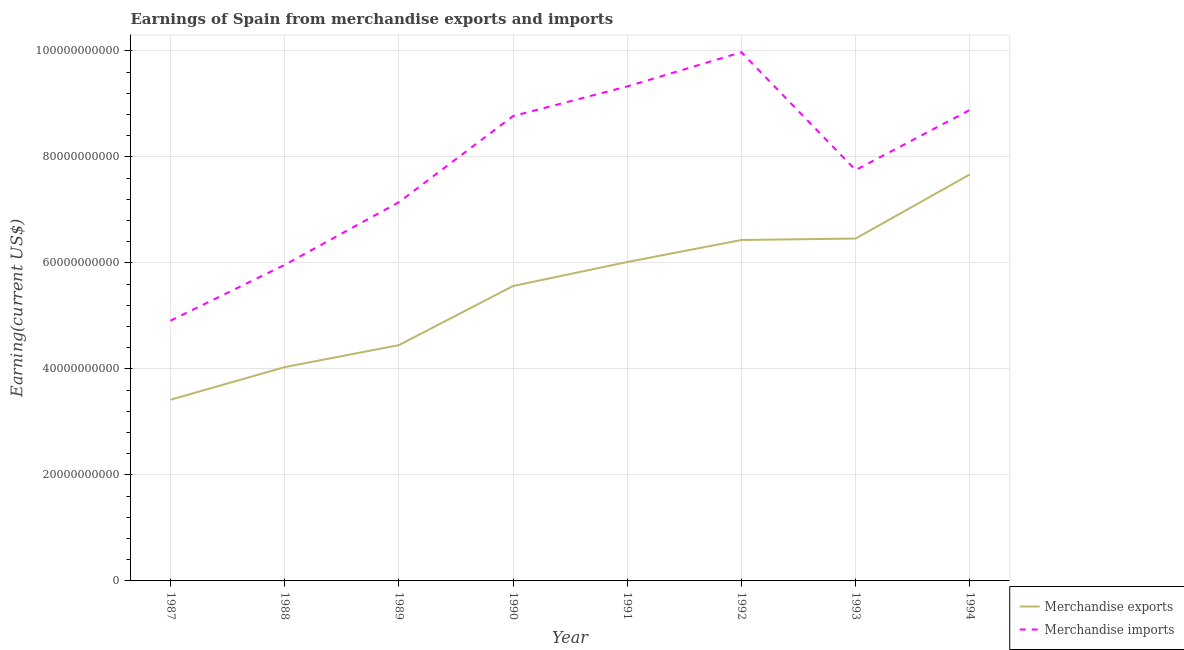Does the line corresponding to earnings from merchandise imports intersect with the line corresponding to earnings from merchandise exports?
Your response must be concise. No. Is the number of lines equal to the number of legend labels?
Your response must be concise. Yes. What is the earnings from merchandise imports in 1990?
Provide a succinct answer. 8.77e+1. Across all years, what is the maximum earnings from merchandise imports?
Ensure brevity in your answer.  9.98e+1. Across all years, what is the minimum earnings from merchandise exports?
Your response must be concise. 3.42e+1. In which year was the earnings from merchandise imports maximum?
Your answer should be compact. 1992. What is the total earnings from merchandise exports in the graph?
Offer a very short reply. 4.40e+11. What is the difference between the earnings from merchandise imports in 1991 and that in 1992?
Keep it short and to the point. -6.45e+09. What is the difference between the earnings from merchandise exports in 1991 and the earnings from merchandise imports in 1989?
Your response must be concise. -1.13e+1. What is the average earnings from merchandise imports per year?
Your answer should be compact. 7.84e+1. In the year 1991, what is the difference between the earnings from merchandise exports and earnings from merchandise imports?
Ensure brevity in your answer.  -3.31e+1. In how many years, is the earnings from merchandise imports greater than 16000000000 US$?
Give a very brief answer. 8. What is the ratio of the earnings from merchandise imports in 1987 to that in 1989?
Make the answer very short. 0.69. Is the earnings from merchandise exports in 1991 less than that in 1993?
Your response must be concise. Yes. What is the difference between the highest and the second highest earnings from merchandise exports?
Offer a very short reply. 1.21e+1. What is the difference between the highest and the lowest earnings from merchandise imports?
Provide a succinct answer. 5.06e+1. Is the earnings from merchandise imports strictly greater than the earnings from merchandise exports over the years?
Make the answer very short. Yes. How many lines are there?
Ensure brevity in your answer.  2. How many years are there in the graph?
Your answer should be compact. 8. What is the difference between two consecutive major ticks on the Y-axis?
Provide a short and direct response. 2.00e+1. Are the values on the major ticks of Y-axis written in scientific E-notation?
Keep it short and to the point. No. Does the graph contain any zero values?
Make the answer very short. No. Does the graph contain grids?
Ensure brevity in your answer.  Yes. Where does the legend appear in the graph?
Offer a very short reply. Bottom right. What is the title of the graph?
Your response must be concise. Earnings of Spain from merchandise exports and imports. What is the label or title of the X-axis?
Provide a short and direct response. Year. What is the label or title of the Y-axis?
Provide a succinct answer. Earning(current US$). What is the Earning(current US$) in Merchandise exports in 1987?
Provide a short and direct response. 3.42e+1. What is the Earning(current US$) of Merchandise imports in 1987?
Keep it short and to the point. 4.91e+1. What is the Earning(current US$) of Merchandise exports in 1988?
Your answer should be very brief. 4.03e+1. What is the Earning(current US$) of Merchandise imports in 1988?
Your answer should be very brief. 5.96e+1. What is the Earning(current US$) in Merchandise exports in 1989?
Offer a very short reply. 4.45e+1. What is the Earning(current US$) of Merchandise imports in 1989?
Give a very brief answer. 7.15e+1. What is the Earning(current US$) in Merchandise exports in 1990?
Keep it short and to the point. 5.56e+1. What is the Earning(current US$) of Merchandise imports in 1990?
Offer a very short reply. 8.77e+1. What is the Earning(current US$) in Merchandise exports in 1991?
Ensure brevity in your answer.  6.02e+1. What is the Earning(current US$) in Merchandise imports in 1991?
Offer a terse response. 9.33e+1. What is the Earning(current US$) in Merchandise exports in 1992?
Provide a short and direct response. 6.43e+1. What is the Earning(current US$) of Merchandise imports in 1992?
Provide a short and direct response. 9.98e+1. What is the Earning(current US$) in Merchandise exports in 1993?
Ensure brevity in your answer.  6.46e+1. What is the Earning(current US$) of Merchandise imports in 1993?
Ensure brevity in your answer.  7.75e+1. What is the Earning(current US$) in Merchandise exports in 1994?
Offer a terse response. 7.67e+1. What is the Earning(current US$) in Merchandise imports in 1994?
Provide a short and direct response. 8.89e+1. Across all years, what is the maximum Earning(current US$) of Merchandise exports?
Your answer should be very brief. 7.67e+1. Across all years, what is the maximum Earning(current US$) of Merchandise imports?
Keep it short and to the point. 9.98e+1. Across all years, what is the minimum Earning(current US$) in Merchandise exports?
Offer a terse response. 3.42e+1. Across all years, what is the minimum Earning(current US$) of Merchandise imports?
Make the answer very short. 4.91e+1. What is the total Earning(current US$) of Merchandise exports in the graph?
Make the answer very short. 4.40e+11. What is the total Earning(current US$) of Merchandise imports in the graph?
Your answer should be compact. 6.27e+11. What is the difference between the Earning(current US$) of Merchandise exports in 1987 and that in 1988?
Keep it short and to the point. -6.15e+09. What is the difference between the Earning(current US$) of Merchandise imports in 1987 and that in 1988?
Keep it short and to the point. -1.05e+1. What is the difference between the Earning(current US$) in Merchandise exports in 1987 and that in 1989?
Ensure brevity in your answer.  -1.03e+1. What is the difference between the Earning(current US$) of Merchandise imports in 1987 and that in 1989?
Keep it short and to the point. -2.24e+1. What is the difference between the Earning(current US$) of Merchandise exports in 1987 and that in 1990?
Give a very brief answer. -2.14e+1. What is the difference between the Earning(current US$) in Merchandise imports in 1987 and that in 1990?
Make the answer very short. -3.86e+1. What is the difference between the Earning(current US$) in Merchandise exports in 1987 and that in 1991?
Your answer should be very brief. -2.60e+1. What is the difference between the Earning(current US$) in Merchandise imports in 1987 and that in 1991?
Make the answer very short. -4.42e+1. What is the difference between the Earning(current US$) of Merchandise exports in 1987 and that in 1992?
Your response must be concise. -3.01e+1. What is the difference between the Earning(current US$) of Merchandise imports in 1987 and that in 1992?
Your answer should be compact. -5.06e+1. What is the difference between the Earning(current US$) in Merchandise exports in 1987 and that in 1993?
Ensure brevity in your answer.  -3.04e+1. What is the difference between the Earning(current US$) in Merchandise imports in 1987 and that in 1993?
Keep it short and to the point. -2.84e+1. What is the difference between the Earning(current US$) in Merchandise exports in 1987 and that in 1994?
Give a very brief answer. -4.25e+1. What is the difference between the Earning(current US$) of Merchandise imports in 1987 and that in 1994?
Make the answer very short. -3.98e+1. What is the difference between the Earning(current US$) in Merchandise exports in 1988 and that in 1989?
Offer a very short reply. -4.15e+09. What is the difference between the Earning(current US$) of Merchandise imports in 1988 and that in 1989?
Your response must be concise. -1.18e+1. What is the difference between the Earning(current US$) of Merchandise exports in 1988 and that in 1990?
Give a very brief answer. -1.53e+1. What is the difference between the Earning(current US$) of Merchandise imports in 1988 and that in 1990?
Offer a terse response. -2.81e+1. What is the difference between the Earning(current US$) of Merchandise exports in 1988 and that in 1991?
Keep it short and to the point. -1.98e+1. What is the difference between the Earning(current US$) in Merchandise imports in 1988 and that in 1991?
Provide a succinct answer. -3.37e+1. What is the difference between the Earning(current US$) in Merchandise exports in 1988 and that in 1992?
Ensure brevity in your answer.  -2.40e+1. What is the difference between the Earning(current US$) of Merchandise imports in 1988 and that in 1992?
Ensure brevity in your answer.  -4.01e+1. What is the difference between the Earning(current US$) of Merchandise exports in 1988 and that in 1993?
Make the answer very short. -2.43e+1. What is the difference between the Earning(current US$) of Merchandise imports in 1988 and that in 1993?
Give a very brief answer. -1.79e+1. What is the difference between the Earning(current US$) in Merchandise exports in 1988 and that in 1994?
Make the answer very short. -3.64e+1. What is the difference between the Earning(current US$) of Merchandise imports in 1988 and that in 1994?
Provide a succinct answer. -2.92e+1. What is the difference between the Earning(current US$) in Merchandise exports in 1989 and that in 1990?
Provide a succinct answer. -1.12e+1. What is the difference between the Earning(current US$) in Merchandise imports in 1989 and that in 1990?
Keep it short and to the point. -1.62e+1. What is the difference between the Earning(current US$) in Merchandise exports in 1989 and that in 1991?
Your response must be concise. -1.57e+1. What is the difference between the Earning(current US$) of Merchandise imports in 1989 and that in 1991?
Your answer should be compact. -2.18e+1. What is the difference between the Earning(current US$) of Merchandise exports in 1989 and that in 1992?
Provide a short and direct response. -1.98e+1. What is the difference between the Earning(current US$) of Merchandise imports in 1989 and that in 1992?
Your response must be concise. -2.83e+1. What is the difference between the Earning(current US$) of Merchandise exports in 1989 and that in 1993?
Your answer should be very brief. -2.01e+1. What is the difference between the Earning(current US$) of Merchandise imports in 1989 and that in 1993?
Your response must be concise. -6.06e+09. What is the difference between the Earning(current US$) of Merchandise exports in 1989 and that in 1994?
Keep it short and to the point. -3.22e+1. What is the difference between the Earning(current US$) in Merchandise imports in 1989 and that in 1994?
Make the answer very short. -1.74e+1. What is the difference between the Earning(current US$) in Merchandise exports in 1990 and that in 1991?
Give a very brief answer. -4.54e+09. What is the difference between the Earning(current US$) of Merchandise imports in 1990 and that in 1991?
Ensure brevity in your answer.  -5.59e+09. What is the difference between the Earning(current US$) of Merchandise exports in 1990 and that in 1992?
Your answer should be compact. -8.69e+09. What is the difference between the Earning(current US$) in Merchandise imports in 1990 and that in 1992?
Your answer should be compact. -1.20e+1. What is the difference between the Earning(current US$) of Merchandise exports in 1990 and that in 1993?
Your answer should be very brief. -8.96e+09. What is the difference between the Earning(current US$) in Merchandise imports in 1990 and that in 1993?
Keep it short and to the point. 1.02e+1. What is the difference between the Earning(current US$) in Merchandise exports in 1990 and that in 1994?
Your answer should be very brief. -2.11e+1. What is the difference between the Earning(current US$) of Merchandise imports in 1990 and that in 1994?
Your answer should be very brief. -1.15e+09. What is the difference between the Earning(current US$) of Merchandise exports in 1991 and that in 1992?
Offer a terse response. -4.16e+09. What is the difference between the Earning(current US$) in Merchandise imports in 1991 and that in 1992?
Your response must be concise. -6.45e+09. What is the difference between the Earning(current US$) of Merchandise exports in 1991 and that in 1993?
Ensure brevity in your answer.  -4.43e+09. What is the difference between the Earning(current US$) in Merchandise imports in 1991 and that in 1993?
Make the answer very short. 1.58e+1. What is the difference between the Earning(current US$) in Merchandise exports in 1991 and that in 1994?
Your answer should be very brief. -1.65e+1. What is the difference between the Earning(current US$) in Merchandise imports in 1991 and that in 1994?
Offer a terse response. 4.44e+09. What is the difference between the Earning(current US$) in Merchandise exports in 1992 and that in 1993?
Offer a terse response. -2.69e+08. What is the difference between the Earning(current US$) in Merchandise imports in 1992 and that in 1993?
Give a very brief answer. 2.22e+1. What is the difference between the Earning(current US$) in Merchandise exports in 1992 and that in 1994?
Make the answer very short. -1.24e+1. What is the difference between the Earning(current US$) in Merchandise imports in 1992 and that in 1994?
Provide a short and direct response. 1.09e+1. What is the difference between the Earning(current US$) of Merchandise exports in 1993 and that in 1994?
Provide a succinct answer. -1.21e+1. What is the difference between the Earning(current US$) in Merchandise imports in 1993 and that in 1994?
Provide a succinct answer. -1.13e+1. What is the difference between the Earning(current US$) in Merchandise exports in 1987 and the Earning(current US$) in Merchandise imports in 1988?
Make the answer very short. -2.55e+1. What is the difference between the Earning(current US$) in Merchandise exports in 1987 and the Earning(current US$) in Merchandise imports in 1989?
Your response must be concise. -3.73e+1. What is the difference between the Earning(current US$) of Merchandise exports in 1987 and the Earning(current US$) of Merchandise imports in 1990?
Provide a succinct answer. -5.35e+1. What is the difference between the Earning(current US$) in Merchandise exports in 1987 and the Earning(current US$) in Merchandise imports in 1991?
Keep it short and to the point. -5.91e+1. What is the difference between the Earning(current US$) in Merchandise exports in 1987 and the Earning(current US$) in Merchandise imports in 1992?
Give a very brief answer. -6.56e+1. What is the difference between the Earning(current US$) of Merchandise exports in 1987 and the Earning(current US$) of Merchandise imports in 1993?
Offer a terse response. -4.33e+1. What is the difference between the Earning(current US$) in Merchandise exports in 1987 and the Earning(current US$) in Merchandise imports in 1994?
Your response must be concise. -5.47e+1. What is the difference between the Earning(current US$) of Merchandise exports in 1988 and the Earning(current US$) of Merchandise imports in 1989?
Keep it short and to the point. -3.11e+1. What is the difference between the Earning(current US$) of Merchandise exports in 1988 and the Earning(current US$) of Merchandise imports in 1990?
Give a very brief answer. -4.74e+1. What is the difference between the Earning(current US$) in Merchandise exports in 1988 and the Earning(current US$) in Merchandise imports in 1991?
Give a very brief answer. -5.30e+1. What is the difference between the Earning(current US$) of Merchandise exports in 1988 and the Earning(current US$) of Merchandise imports in 1992?
Offer a very short reply. -5.94e+1. What is the difference between the Earning(current US$) in Merchandise exports in 1988 and the Earning(current US$) in Merchandise imports in 1993?
Provide a short and direct response. -3.72e+1. What is the difference between the Earning(current US$) of Merchandise exports in 1988 and the Earning(current US$) of Merchandise imports in 1994?
Offer a very short reply. -4.85e+1. What is the difference between the Earning(current US$) in Merchandise exports in 1989 and the Earning(current US$) in Merchandise imports in 1990?
Your response must be concise. -4.32e+1. What is the difference between the Earning(current US$) of Merchandise exports in 1989 and the Earning(current US$) of Merchandise imports in 1991?
Provide a succinct answer. -4.88e+1. What is the difference between the Earning(current US$) of Merchandise exports in 1989 and the Earning(current US$) of Merchandise imports in 1992?
Your answer should be very brief. -5.53e+1. What is the difference between the Earning(current US$) in Merchandise exports in 1989 and the Earning(current US$) in Merchandise imports in 1993?
Your answer should be very brief. -3.30e+1. What is the difference between the Earning(current US$) of Merchandise exports in 1989 and the Earning(current US$) of Merchandise imports in 1994?
Offer a terse response. -4.44e+1. What is the difference between the Earning(current US$) of Merchandise exports in 1990 and the Earning(current US$) of Merchandise imports in 1991?
Offer a very short reply. -3.77e+1. What is the difference between the Earning(current US$) in Merchandise exports in 1990 and the Earning(current US$) in Merchandise imports in 1992?
Make the answer very short. -4.41e+1. What is the difference between the Earning(current US$) of Merchandise exports in 1990 and the Earning(current US$) of Merchandise imports in 1993?
Your answer should be very brief. -2.19e+1. What is the difference between the Earning(current US$) in Merchandise exports in 1990 and the Earning(current US$) in Merchandise imports in 1994?
Offer a very short reply. -3.32e+1. What is the difference between the Earning(current US$) in Merchandise exports in 1991 and the Earning(current US$) in Merchandise imports in 1992?
Offer a very short reply. -3.96e+1. What is the difference between the Earning(current US$) in Merchandise exports in 1991 and the Earning(current US$) in Merchandise imports in 1993?
Offer a very short reply. -1.73e+1. What is the difference between the Earning(current US$) of Merchandise exports in 1991 and the Earning(current US$) of Merchandise imports in 1994?
Offer a very short reply. -2.87e+1. What is the difference between the Earning(current US$) in Merchandise exports in 1992 and the Earning(current US$) in Merchandise imports in 1993?
Provide a short and direct response. -1.32e+1. What is the difference between the Earning(current US$) of Merchandise exports in 1992 and the Earning(current US$) of Merchandise imports in 1994?
Provide a succinct answer. -2.45e+1. What is the difference between the Earning(current US$) of Merchandise exports in 1993 and the Earning(current US$) of Merchandise imports in 1994?
Make the answer very short. -2.43e+1. What is the average Earning(current US$) in Merchandise exports per year?
Make the answer very short. 5.51e+1. What is the average Earning(current US$) in Merchandise imports per year?
Your response must be concise. 7.84e+1. In the year 1987, what is the difference between the Earning(current US$) of Merchandise exports and Earning(current US$) of Merchandise imports?
Make the answer very short. -1.49e+1. In the year 1988, what is the difference between the Earning(current US$) of Merchandise exports and Earning(current US$) of Merchandise imports?
Make the answer very short. -1.93e+1. In the year 1989, what is the difference between the Earning(current US$) in Merchandise exports and Earning(current US$) in Merchandise imports?
Ensure brevity in your answer.  -2.70e+1. In the year 1990, what is the difference between the Earning(current US$) of Merchandise exports and Earning(current US$) of Merchandise imports?
Your response must be concise. -3.21e+1. In the year 1991, what is the difference between the Earning(current US$) in Merchandise exports and Earning(current US$) in Merchandise imports?
Keep it short and to the point. -3.31e+1. In the year 1992, what is the difference between the Earning(current US$) in Merchandise exports and Earning(current US$) in Merchandise imports?
Keep it short and to the point. -3.54e+1. In the year 1993, what is the difference between the Earning(current US$) in Merchandise exports and Earning(current US$) in Merchandise imports?
Provide a short and direct response. -1.29e+1. In the year 1994, what is the difference between the Earning(current US$) of Merchandise exports and Earning(current US$) of Merchandise imports?
Offer a very short reply. -1.22e+1. What is the ratio of the Earning(current US$) in Merchandise exports in 1987 to that in 1988?
Offer a very short reply. 0.85. What is the ratio of the Earning(current US$) in Merchandise imports in 1987 to that in 1988?
Offer a very short reply. 0.82. What is the ratio of the Earning(current US$) of Merchandise exports in 1987 to that in 1989?
Offer a very short reply. 0.77. What is the ratio of the Earning(current US$) in Merchandise imports in 1987 to that in 1989?
Ensure brevity in your answer.  0.69. What is the ratio of the Earning(current US$) in Merchandise exports in 1987 to that in 1990?
Offer a very short reply. 0.61. What is the ratio of the Earning(current US$) of Merchandise imports in 1987 to that in 1990?
Your answer should be very brief. 0.56. What is the ratio of the Earning(current US$) in Merchandise exports in 1987 to that in 1991?
Ensure brevity in your answer.  0.57. What is the ratio of the Earning(current US$) of Merchandise imports in 1987 to that in 1991?
Your answer should be very brief. 0.53. What is the ratio of the Earning(current US$) in Merchandise exports in 1987 to that in 1992?
Offer a terse response. 0.53. What is the ratio of the Earning(current US$) in Merchandise imports in 1987 to that in 1992?
Ensure brevity in your answer.  0.49. What is the ratio of the Earning(current US$) of Merchandise exports in 1987 to that in 1993?
Your answer should be very brief. 0.53. What is the ratio of the Earning(current US$) of Merchandise imports in 1987 to that in 1993?
Give a very brief answer. 0.63. What is the ratio of the Earning(current US$) of Merchandise exports in 1987 to that in 1994?
Your response must be concise. 0.45. What is the ratio of the Earning(current US$) in Merchandise imports in 1987 to that in 1994?
Provide a succinct answer. 0.55. What is the ratio of the Earning(current US$) in Merchandise exports in 1988 to that in 1989?
Your answer should be very brief. 0.91. What is the ratio of the Earning(current US$) in Merchandise imports in 1988 to that in 1989?
Offer a very short reply. 0.83. What is the ratio of the Earning(current US$) of Merchandise exports in 1988 to that in 1990?
Give a very brief answer. 0.72. What is the ratio of the Earning(current US$) of Merchandise imports in 1988 to that in 1990?
Ensure brevity in your answer.  0.68. What is the ratio of the Earning(current US$) in Merchandise exports in 1988 to that in 1991?
Ensure brevity in your answer.  0.67. What is the ratio of the Earning(current US$) of Merchandise imports in 1988 to that in 1991?
Offer a very short reply. 0.64. What is the ratio of the Earning(current US$) of Merchandise exports in 1988 to that in 1992?
Keep it short and to the point. 0.63. What is the ratio of the Earning(current US$) of Merchandise imports in 1988 to that in 1992?
Your response must be concise. 0.6. What is the ratio of the Earning(current US$) of Merchandise exports in 1988 to that in 1993?
Ensure brevity in your answer.  0.62. What is the ratio of the Earning(current US$) of Merchandise imports in 1988 to that in 1993?
Your response must be concise. 0.77. What is the ratio of the Earning(current US$) of Merchandise exports in 1988 to that in 1994?
Keep it short and to the point. 0.53. What is the ratio of the Earning(current US$) in Merchandise imports in 1988 to that in 1994?
Give a very brief answer. 0.67. What is the ratio of the Earning(current US$) in Merchandise exports in 1989 to that in 1990?
Offer a very short reply. 0.8. What is the ratio of the Earning(current US$) in Merchandise imports in 1989 to that in 1990?
Your response must be concise. 0.81. What is the ratio of the Earning(current US$) of Merchandise exports in 1989 to that in 1991?
Your answer should be compact. 0.74. What is the ratio of the Earning(current US$) of Merchandise imports in 1989 to that in 1991?
Offer a very short reply. 0.77. What is the ratio of the Earning(current US$) in Merchandise exports in 1989 to that in 1992?
Ensure brevity in your answer.  0.69. What is the ratio of the Earning(current US$) of Merchandise imports in 1989 to that in 1992?
Make the answer very short. 0.72. What is the ratio of the Earning(current US$) of Merchandise exports in 1989 to that in 1993?
Your answer should be very brief. 0.69. What is the ratio of the Earning(current US$) of Merchandise imports in 1989 to that in 1993?
Provide a short and direct response. 0.92. What is the ratio of the Earning(current US$) in Merchandise exports in 1989 to that in 1994?
Your response must be concise. 0.58. What is the ratio of the Earning(current US$) of Merchandise imports in 1989 to that in 1994?
Ensure brevity in your answer.  0.8. What is the ratio of the Earning(current US$) of Merchandise exports in 1990 to that in 1991?
Give a very brief answer. 0.92. What is the ratio of the Earning(current US$) in Merchandise imports in 1990 to that in 1991?
Provide a short and direct response. 0.94. What is the ratio of the Earning(current US$) in Merchandise exports in 1990 to that in 1992?
Your response must be concise. 0.86. What is the ratio of the Earning(current US$) of Merchandise imports in 1990 to that in 1992?
Your answer should be compact. 0.88. What is the ratio of the Earning(current US$) in Merchandise exports in 1990 to that in 1993?
Provide a short and direct response. 0.86. What is the ratio of the Earning(current US$) in Merchandise imports in 1990 to that in 1993?
Provide a succinct answer. 1.13. What is the ratio of the Earning(current US$) of Merchandise exports in 1990 to that in 1994?
Your answer should be compact. 0.73. What is the ratio of the Earning(current US$) of Merchandise imports in 1990 to that in 1994?
Provide a short and direct response. 0.99. What is the ratio of the Earning(current US$) of Merchandise exports in 1991 to that in 1992?
Offer a terse response. 0.94. What is the ratio of the Earning(current US$) of Merchandise imports in 1991 to that in 1992?
Your answer should be compact. 0.94. What is the ratio of the Earning(current US$) in Merchandise exports in 1991 to that in 1993?
Provide a short and direct response. 0.93. What is the ratio of the Earning(current US$) of Merchandise imports in 1991 to that in 1993?
Your response must be concise. 1.2. What is the ratio of the Earning(current US$) in Merchandise exports in 1991 to that in 1994?
Ensure brevity in your answer.  0.78. What is the ratio of the Earning(current US$) in Merchandise imports in 1991 to that in 1994?
Provide a succinct answer. 1.05. What is the ratio of the Earning(current US$) in Merchandise exports in 1992 to that in 1993?
Your answer should be very brief. 1. What is the ratio of the Earning(current US$) in Merchandise imports in 1992 to that in 1993?
Offer a very short reply. 1.29. What is the ratio of the Earning(current US$) in Merchandise exports in 1992 to that in 1994?
Provide a succinct answer. 0.84. What is the ratio of the Earning(current US$) of Merchandise imports in 1992 to that in 1994?
Your answer should be very brief. 1.12. What is the ratio of the Earning(current US$) of Merchandise exports in 1993 to that in 1994?
Provide a succinct answer. 0.84. What is the ratio of the Earning(current US$) of Merchandise imports in 1993 to that in 1994?
Keep it short and to the point. 0.87. What is the difference between the highest and the second highest Earning(current US$) in Merchandise exports?
Offer a terse response. 1.21e+1. What is the difference between the highest and the second highest Earning(current US$) of Merchandise imports?
Provide a short and direct response. 6.45e+09. What is the difference between the highest and the lowest Earning(current US$) in Merchandise exports?
Provide a succinct answer. 4.25e+1. What is the difference between the highest and the lowest Earning(current US$) in Merchandise imports?
Make the answer very short. 5.06e+1. 